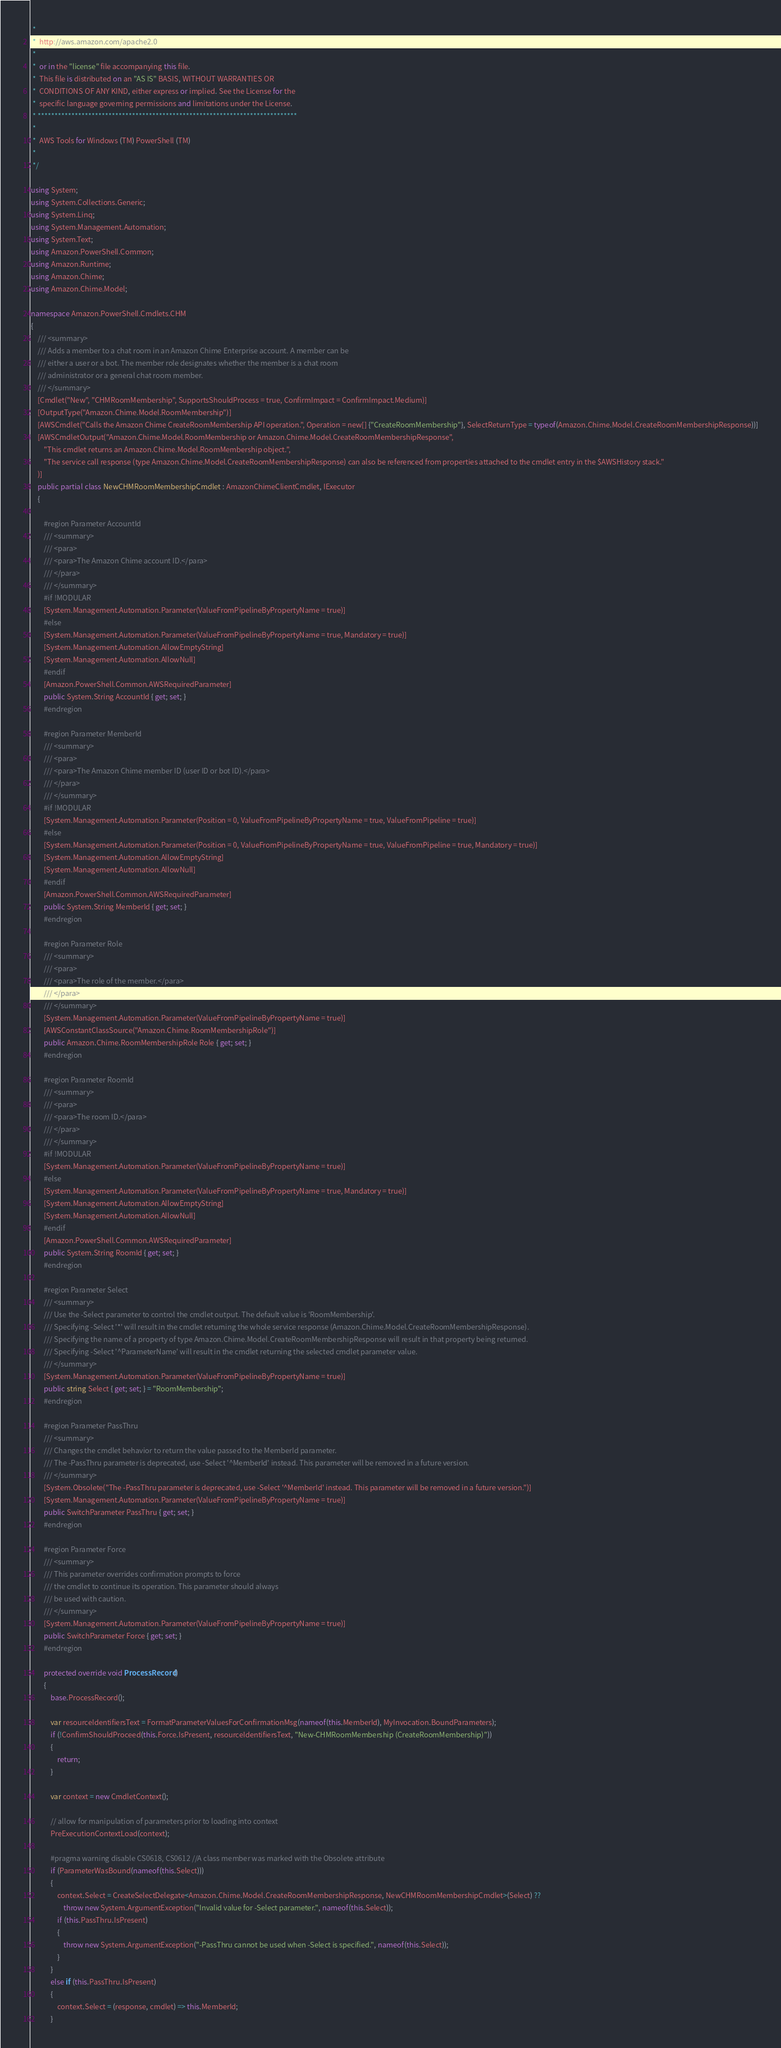Convert code to text. <code><loc_0><loc_0><loc_500><loc_500><_C#_> *
 *  http://aws.amazon.com/apache2.0
 *
 *  or in the "license" file accompanying this file.
 *  This file is distributed on an "AS IS" BASIS, WITHOUT WARRANTIES OR
 *  CONDITIONS OF ANY KIND, either express or implied. See the License for the
 *  specific language governing permissions and limitations under the License.
 * *****************************************************************************
 *
 *  AWS Tools for Windows (TM) PowerShell (TM)
 *
 */

using System;
using System.Collections.Generic;
using System.Linq;
using System.Management.Automation;
using System.Text;
using Amazon.PowerShell.Common;
using Amazon.Runtime;
using Amazon.Chime;
using Amazon.Chime.Model;

namespace Amazon.PowerShell.Cmdlets.CHM
{
    /// <summary>
    /// Adds a member to a chat room in an Amazon Chime Enterprise account. A member can be
    /// either a user or a bot. The member role designates whether the member is a chat room
    /// administrator or a general chat room member.
    /// </summary>
    [Cmdlet("New", "CHMRoomMembership", SupportsShouldProcess = true, ConfirmImpact = ConfirmImpact.Medium)]
    [OutputType("Amazon.Chime.Model.RoomMembership")]
    [AWSCmdlet("Calls the Amazon Chime CreateRoomMembership API operation.", Operation = new[] {"CreateRoomMembership"}, SelectReturnType = typeof(Amazon.Chime.Model.CreateRoomMembershipResponse))]
    [AWSCmdletOutput("Amazon.Chime.Model.RoomMembership or Amazon.Chime.Model.CreateRoomMembershipResponse",
        "This cmdlet returns an Amazon.Chime.Model.RoomMembership object.",
        "The service call response (type Amazon.Chime.Model.CreateRoomMembershipResponse) can also be referenced from properties attached to the cmdlet entry in the $AWSHistory stack."
    )]
    public partial class NewCHMRoomMembershipCmdlet : AmazonChimeClientCmdlet, IExecutor
    {
        
        #region Parameter AccountId
        /// <summary>
        /// <para>
        /// <para>The Amazon Chime account ID.</para>
        /// </para>
        /// </summary>
        #if !MODULAR
        [System.Management.Automation.Parameter(ValueFromPipelineByPropertyName = true)]
        #else
        [System.Management.Automation.Parameter(ValueFromPipelineByPropertyName = true, Mandatory = true)]
        [System.Management.Automation.AllowEmptyString]
        [System.Management.Automation.AllowNull]
        #endif
        [Amazon.PowerShell.Common.AWSRequiredParameter]
        public System.String AccountId { get; set; }
        #endregion
        
        #region Parameter MemberId
        /// <summary>
        /// <para>
        /// <para>The Amazon Chime member ID (user ID or bot ID).</para>
        /// </para>
        /// </summary>
        #if !MODULAR
        [System.Management.Automation.Parameter(Position = 0, ValueFromPipelineByPropertyName = true, ValueFromPipeline = true)]
        #else
        [System.Management.Automation.Parameter(Position = 0, ValueFromPipelineByPropertyName = true, ValueFromPipeline = true, Mandatory = true)]
        [System.Management.Automation.AllowEmptyString]
        [System.Management.Automation.AllowNull]
        #endif
        [Amazon.PowerShell.Common.AWSRequiredParameter]
        public System.String MemberId { get; set; }
        #endregion
        
        #region Parameter Role
        /// <summary>
        /// <para>
        /// <para>The role of the member.</para>
        /// </para>
        /// </summary>
        [System.Management.Automation.Parameter(ValueFromPipelineByPropertyName = true)]
        [AWSConstantClassSource("Amazon.Chime.RoomMembershipRole")]
        public Amazon.Chime.RoomMembershipRole Role { get; set; }
        #endregion
        
        #region Parameter RoomId
        /// <summary>
        /// <para>
        /// <para>The room ID.</para>
        /// </para>
        /// </summary>
        #if !MODULAR
        [System.Management.Automation.Parameter(ValueFromPipelineByPropertyName = true)]
        #else
        [System.Management.Automation.Parameter(ValueFromPipelineByPropertyName = true, Mandatory = true)]
        [System.Management.Automation.AllowEmptyString]
        [System.Management.Automation.AllowNull]
        #endif
        [Amazon.PowerShell.Common.AWSRequiredParameter]
        public System.String RoomId { get; set; }
        #endregion
        
        #region Parameter Select
        /// <summary>
        /// Use the -Select parameter to control the cmdlet output. The default value is 'RoomMembership'.
        /// Specifying -Select '*' will result in the cmdlet returning the whole service response (Amazon.Chime.Model.CreateRoomMembershipResponse).
        /// Specifying the name of a property of type Amazon.Chime.Model.CreateRoomMembershipResponse will result in that property being returned.
        /// Specifying -Select '^ParameterName' will result in the cmdlet returning the selected cmdlet parameter value.
        /// </summary>
        [System.Management.Automation.Parameter(ValueFromPipelineByPropertyName = true)]
        public string Select { get; set; } = "RoomMembership";
        #endregion
        
        #region Parameter PassThru
        /// <summary>
        /// Changes the cmdlet behavior to return the value passed to the MemberId parameter.
        /// The -PassThru parameter is deprecated, use -Select '^MemberId' instead. This parameter will be removed in a future version.
        /// </summary>
        [System.Obsolete("The -PassThru parameter is deprecated, use -Select '^MemberId' instead. This parameter will be removed in a future version.")]
        [System.Management.Automation.Parameter(ValueFromPipelineByPropertyName = true)]
        public SwitchParameter PassThru { get; set; }
        #endregion
        
        #region Parameter Force
        /// <summary>
        /// This parameter overrides confirmation prompts to force 
        /// the cmdlet to continue its operation. This parameter should always
        /// be used with caution.
        /// </summary>
        [System.Management.Automation.Parameter(ValueFromPipelineByPropertyName = true)]
        public SwitchParameter Force { get; set; }
        #endregion
        
        protected override void ProcessRecord()
        {
            base.ProcessRecord();
            
            var resourceIdentifiersText = FormatParameterValuesForConfirmationMsg(nameof(this.MemberId), MyInvocation.BoundParameters);
            if (!ConfirmShouldProceed(this.Force.IsPresent, resourceIdentifiersText, "New-CHMRoomMembership (CreateRoomMembership)"))
            {
                return;
            }
            
            var context = new CmdletContext();
            
            // allow for manipulation of parameters prior to loading into context
            PreExecutionContextLoad(context);
            
            #pragma warning disable CS0618, CS0612 //A class member was marked with the Obsolete attribute
            if (ParameterWasBound(nameof(this.Select)))
            {
                context.Select = CreateSelectDelegate<Amazon.Chime.Model.CreateRoomMembershipResponse, NewCHMRoomMembershipCmdlet>(Select) ??
                    throw new System.ArgumentException("Invalid value for -Select parameter.", nameof(this.Select));
                if (this.PassThru.IsPresent)
                {
                    throw new System.ArgumentException("-PassThru cannot be used when -Select is specified.", nameof(this.Select));
                }
            }
            else if (this.PassThru.IsPresent)
            {
                context.Select = (response, cmdlet) => this.MemberId;
            }</code> 